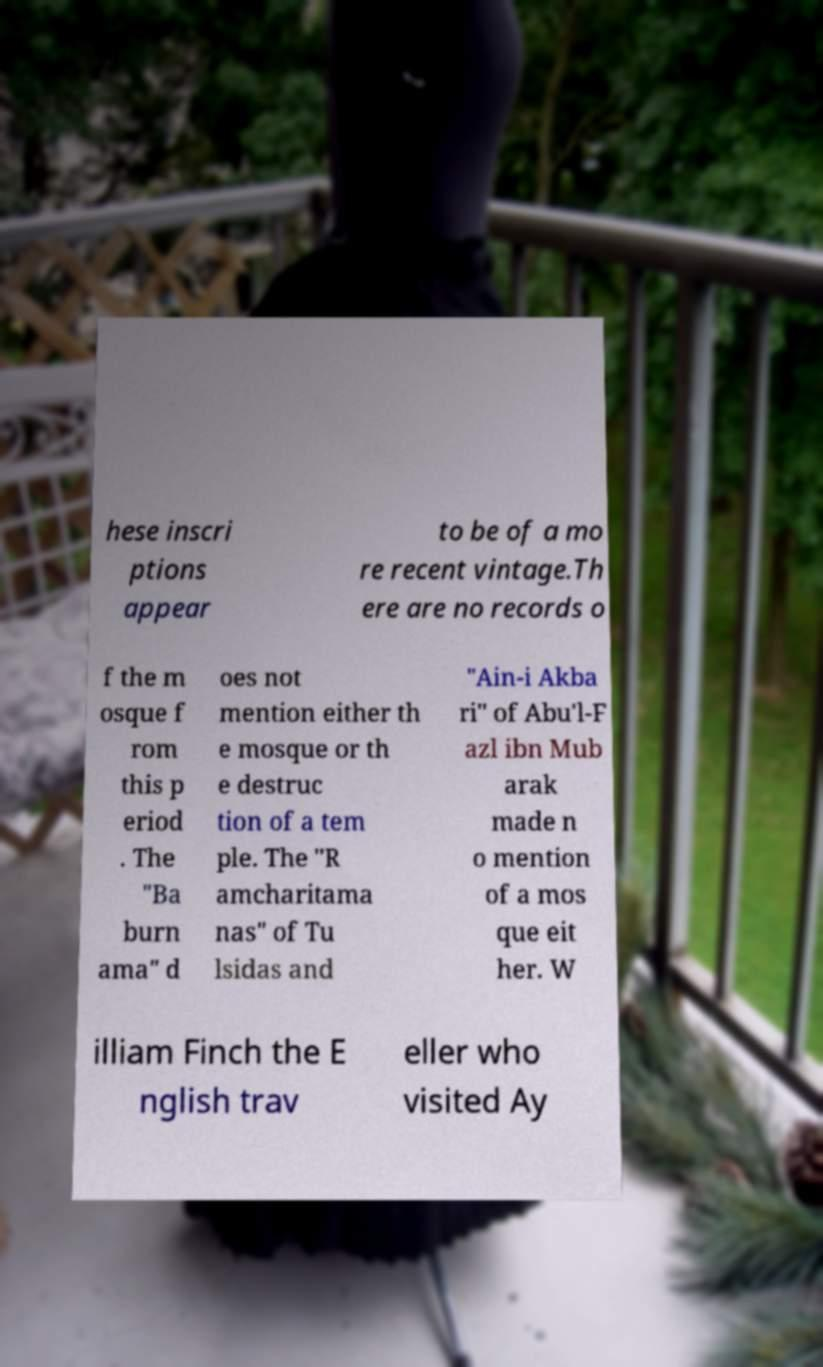Could you extract and type out the text from this image? hese inscri ptions appear to be of a mo re recent vintage.Th ere are no records o f the m osque f rom this p eriod . The "Ba burn ama" d oes not mention either th e mosque or th e destruc tion of a tem ple. The "R amcharitama nas" of Tu lsidas and "Ain-i Akba ri" of Abu'l-F azl ibn Mub arak made n o mention of a mos que eit her. W illiam Finch the E nglish trav eller who visited Ay 